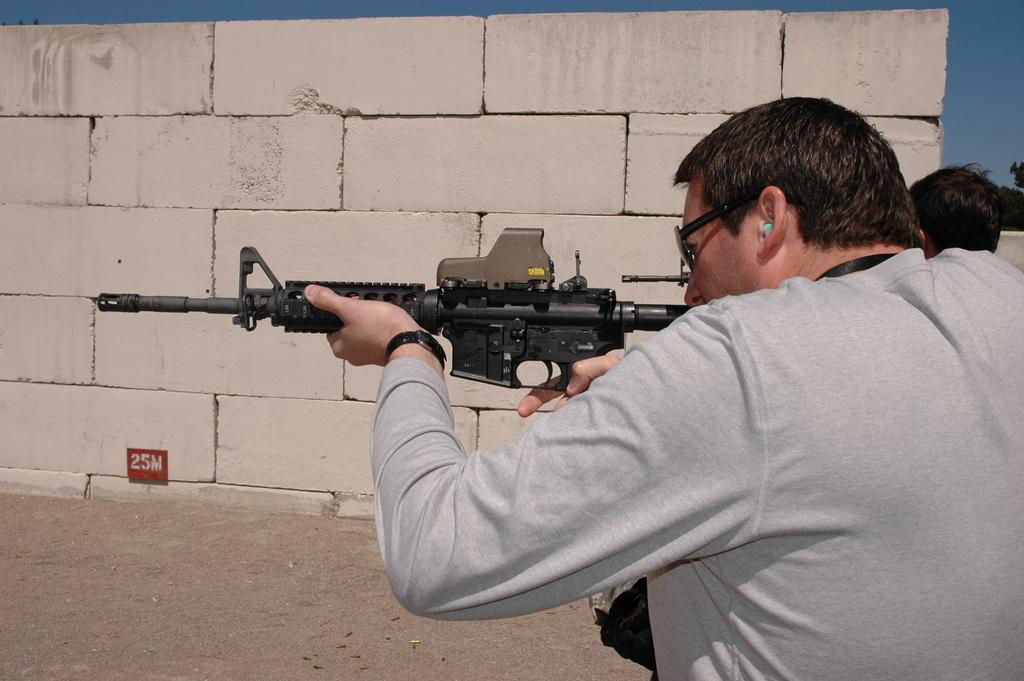What is the person in the image wearing? The person is wearing a grey T-shirt in the image. What is the person holding in their hands? The person is holding a gun in their hands. Can you describe the other person in the image? There is another person beside the first person. What can be seen in the background of the image? There is a brick wall in the background of the image. What type of bread can be seen on the wall in the image? There is no bread present in the image; it features a person holding a gun and a brick wall in the background. 